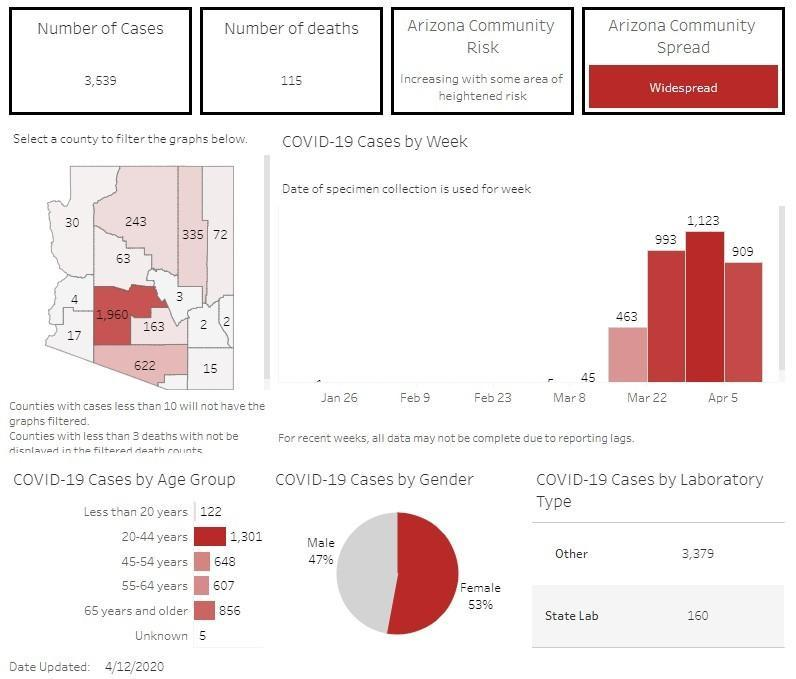What percentage of covid patients in Arizona are females as of 4/12/2020?
Answer the question with a short phrase. 53% Which age group people in Arizona had reported the highest number of Covid-19 cases as of 4/12/2020? 20-44 years What percentage of covid patients in Arizona are males as of 4/12/2020? 47% How many COVID-19 tests were done in  other laboratories other than the state laboratory of Arizona as of 4/12/2020? 3,379 How many COVID-19 tests were done in the state laboratory of Arizona as of 4/12/2020? 160 What is the total number of positive cases of COVID-19 reported in Arizona as of 4/12/2020? 3,539 What is the number of COVID-19 deaths reported in Arizona as of 4/12/2020? 115 How many Covid-19 cases were reported in the people of Arizona aged 20-44 years as of 4/12/2020? 1,301 How many Covid-19 cases were reported in the people of Arizona aged 65+ years as of 4/12/2020? 856 